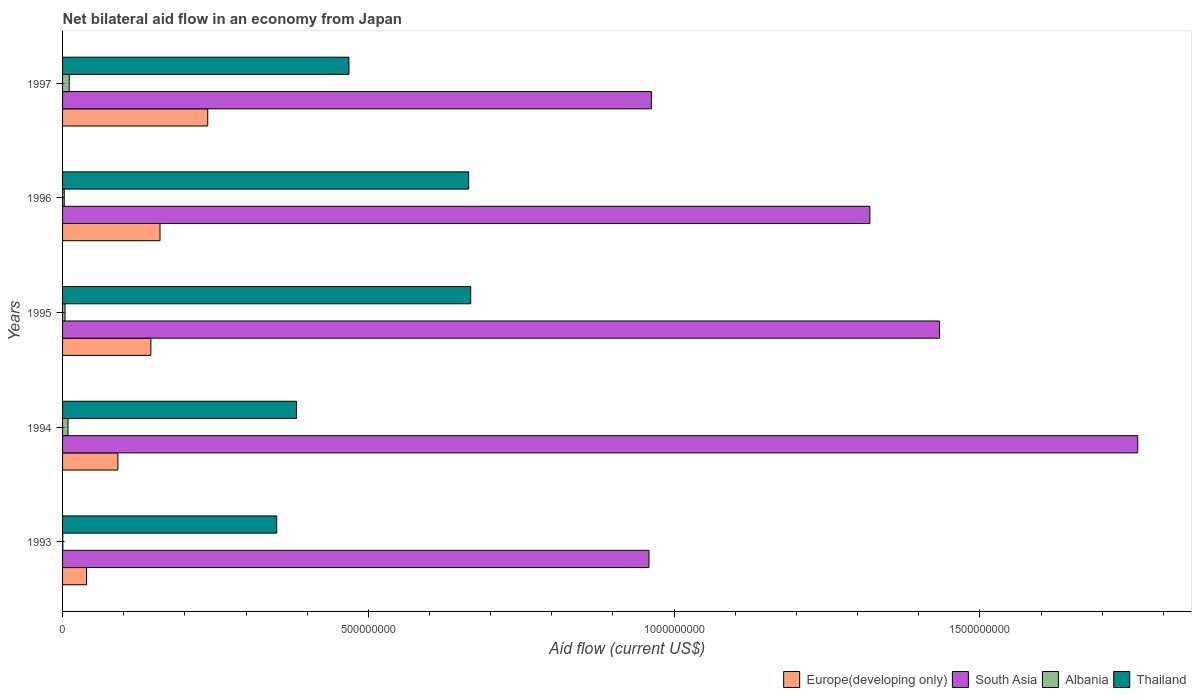How many bars are there on the 5th tick from the top?
Your answer should be very brief. 4. How many bars are there on the 4th tick from the bottom?
Give a very brief answer. 4. What is the label of the 1st group of bars from the top?
Ensure brevity in your answer.  1997. What is the net bilateral aid flow in Albania in 1996?
Your response must be concise. 2.70e+06. Across all years, what is the maximum net bilateral aid flow in South Asia?
Keep it short and to the point. 1.76e+09. Across all years, what is the minimum net bilateral aid flow in Europe(developing only)?
Provide a short and direct response. 3.93e+07. In which year was the net bilateral aid flow in Europe(developing only) maximum?
Keep it short and to the point. 1997. What is the total net bilateral aid flow in Thailand in the graph?
Provide a short and direct response. 2.53e+09. What is the difference between the net bilateral aid flow in Europe(developing only) in 1996 and that in 1997?
Give a very brief answer. -7.80e+07. What is the difference between the net bilateral aid flow in Thailand in 1993 and the net bilateral aid flow in Albania in 1997?
Offer a terse response. 3.39e+08. What is the average net bilateral aid flow in South Asia per year?
Offer a very short reply. 1.29e+09. In the year 1996, what is the difference between the net bilateral aid flow in Albania and net bilateral aid flow in Thailand?
Your answer should be compact. -6.61e+08. What is the ratio of the net bilateral aid flow in South Asia in 1993 to that in 1995?
Provide a short and direct response. 0.67. Is the net bilateral aid flow in Europe(developing only) in 1995 less than that in 1997?
Your response must be concise. Yes. What is the difference between the highest and the second highest net bilateral aid flow in South Asia?
Make the answer very short. 3.24e+08. What is the difference between the highest and the lowest net bilateral aid flow in Albania?
Give a very brief answer. 1.04e+07. In how many years, is the net bilateral aid flow in Europe(developing only) greater than the average net bilateral aid flow in Europe(developing only) taken over all years?
Offer a very short reply. 3. What does the 2nd bar from the top in 1995 represents?
Make the answer very short. Albania. What does the 2nd bar from the bottom in 1997 represents?
Give a very brief answer. South Asia. Is it the case that in every year, the sum of the net bilateral aid flow in Albania and net bilateral aid flow in Thailand is greater than the net bilateral aid flow in South Asia?
Your answer should be compact. No. Are the values on the major ticks of X-axis written in scientific E-notation?
Offer a very short reply. No. Does the graph contain any zero values?
Give a very brief answer. No. Does the graph contain grids?
Offer a very short reply. No. Where does the legend appear in the graph?
Make the answer very short. Bottom right. How many legend labels are there?
Give a very brief answer. 4. What is the title of the graph?
Offer a very short reply. Net bilateral aid flow in an economy from Japan. What is the label or title of the Y-axis?
Offer a terse response. Years. What is the Aid flow (current US$) of Europe(developing only) in 1993?
Provide a short and direct response. 3.93e+07. What is the Aid flow (current US$) of South Asia in 1993?
Provide a short and direct response. 9.59e+08. What is the Aid flow (current US$) of Thailand in 1993?
Keep it short and to the point. 3.50e+08. What is the Aid flow (current US$) in Europe(developing only) in 1994?
Provide a short and direct response. 9.05e+07. What is the Aid flow (current US$) of South Asia in 1994?
Your answer should be very brief. 1.76e+09. What is the Aid flow (current US$) in Albania in 1994?
Your response must be concise. 8.85e+06. What is the Aid flow (current US$) of Thailand in 1994?
Offer a terse response. 3.83e+08. What is the Aid flow (current US$) of Europe(developing only) in 1995?
Provide a succinct answer. 1.44e+08. What is the Aid flow (current US$) of South Asia in 1995?
Make the answer very short. 1.43e+09. What is the Aid flow (current US$) of Albania in 1995?
Your answer should be compact. 4.09e+06. What is the Aid flow (current US$) in Thailand in 1995?
Your answer should be compact. 6.67e+08. What is the Aid flow (current US$) in Europe(developing only) in 1996?
Your answer should be compact. 1.59e+08. What is the Aid flow (current US$) of South Asia in 1996?
Your answer should be very brief. 1.32e+09. What is the Aid flow (current US$) in Albania in 1996?
Give a very brief answer. 2.70e+06. What is the Aid flow (current US$) of Thailand in 1996?
Your response must be concise. 6.64e+08. What is the Aid flow (current US$) of Europe(developing only) in 1997?
Provide a short and direct response. 2.37e+08. What is the Aid flow (current US$) in South Asia in 1997?
Offer a very short reply. 9.63e+08. What is the Aid flow (current US$) in Albania in 1997?
Your answer should be very brief. 1.08e+07. What is the Aid flow (current US$) of Thailand in 1997?
Your answer should be compact. 4.68e+08. Across all years, what is the maximum Aid flow (current US$) of Europe(developing only)?
Provide a short and direct response. 2.37e+08. Across all years, what is the maximum Aid flow (current US$) in South Asia?
Give a very brief answer. 1.76e+09. Across all years, what is the maximum Aid flow (current US$) in Albania?
Your answer should be very brief. 1.08e+07. Across all years, what is the maximum Aid flow (current US$) in Thailand?
Your answer should be compact. 6.67e+08. Across all years, what is the minimum Aid flow (current US$) in Europe(developing only)?
Make the answer very short. 3.93e+07. Across all years, what is the minimum Aid flow (current US$) in South Asia?
Keep it short and to the point. 9.59e+08. Across all years, what is the minimum Aid flow (current US$) of Thailand?
Your response must be concise. 3.50e+08. What is the total Aid flow (current US$) in Europe(developing only) in the graph?
Your answer should be very brief. 6.71e+08. What is the total Aid flow (current US$) in South Asia in the graph?
Give a very brief answer. 6.43e+09. What is the total Aid flow (current US$) in Albania in the graph?
Your answer should be very brief. 2.68e+07. What is the total Aid flow (current US$) of Thailand in the graph?
Provide a short and direct response. 2.53e+09. What is the difference between the Aid flow (current US$) in Europe(developing only) in 1993 and that in 1994?
Offer a very short reply. -5.12e+07. What is the difference between the Aid flow (current US$) of South Asia in 1993 and that in 1994?
Make the answer very short. -7.99e+08. What is the difference between the Aid flow (current US$) of Albania in 1993 and that in 1994?
Make the answer very short. -8.45e+06. What is the difference between the Aid flow (current US$) of Thailand in 1993 and that in 1994?
Offer a terse response. -3.24e+07. What is the difference between the Aid flow (current US$) in Europe(developing only) in 1993 and that in 1995?
Your answer should be compact. -1.05e+08. What is the difference between the Aid flow (current US$) of South Asia in 1993 and that in 1995?
Provide a succinct answer. -4.75e+08. What is the difference between the Aid flow (current US$) of Albania in 1993 and that in 1995?
Your answer should be compact. -3.69e+06. What is the difference between the Aid flow (current US$) in Thailand in 1993 and that in 1995?
Your response must be concise. -3.17e+08. What is the difference between the Aid flow (current US$) of Europe(developing only) in 1993 and that in 1996?
Your response must be concise. -1.20e+08. What is the difference between the Aid flow (current US$) of South Asia in 1993 and that in 1996?
Make the answer very short. -3.61e+08. What is the difference between the Aid flow (current US$) in Albania in 1993 and that in 1996?
Your answer should be very brief. -2.30e+06. What is the difference between the Aid flow (current US$) of Thailand in 1993 and that in 1996?
Ensure brevity in your answer.  -3.14e+08. What is the difference between the Aid flow (current US$) of Europe(developing only) in 1993 and that in 1997?
Keep it short and to the point. -1.98e+08. What is the difference between the Aid flow (current US$) in South Asia in 1993 and that in 1997?
Give a very brief answer. -3.89e+06. What is the difference between the Aid flow (current US$) of Albania in 1993 and that in 1997?
Offer a terse response. -1.04e+07. What is the difference between the Aid flow (current US$) in Thailand in 1993 and that in 1997?
Offer a very short reply. -1.18e+08. What is the difference between the Aid flow (current US$) in Europe(developing only) in 1994 and that in 1995?
Your response must be concise. -5.39e+07. What is the difference between the Aid flow (current US$) of South Asia in 1994 and that in 1995?
Your response must be concise. 3.24e+08. What is the difference between the Aid flow (current US$) of Albania in 1994 and that in 1995?
Your answer should be very brief. 4.76e+06. What is the difference between the Aid flow (current US$) of Thailand in 1994 and that in 1995?
Ensure brevity in your answer.  -2.85e+08. What is the difference between the Aid flow (current US$) of Europe(developing only) in 1994 and that in 1996?
Keep it short and to the point. -6.89e+07. What is the difference between the Aid flow (current US$) of South Asia in 1994 and that in 1996?
Offer a very short reply. 4.38e+08. What is the difference between the Aid flow (current US$) of Albania in 1994 and that in 1996?
Make the answer very short. 6.15e+06. What is the difference between the Aid flow (current US$) of Thailand in 1994 and that in 1996?
Your response must be concise. -2.81e+08. What is the difference between the Aid flow (current US$) in Europe(developing only) in 1994 and that in 1997?
Your answer should be compact. -1.47e+08. What is the difference between the Aid flow (current US$) in South Asia in 1994 and that in 1997?
Give a very brief answer. 7.95e+08. What is the difference between the Aid flow (current US$) of Albania in 1994 and that in 1997?
Offer a terse response. -1.94e+06. What is the difference between the Aid flow (current US$) of Thailand in 1994 and that in 1997?
Provide a succinct answer. -8.57e+07. What is the difference between the Aid flow (current US$) in Europe(developing only) in 1995 and that in 1996?
Ensure brevity in your answer.  -1.50e+07. What is the difference between the Aid flow (current US$) in South Asia in 1995 and that in 1996?
Make the answer very short. 1.14e+08. What is the difference between the Aid flow (current US$) in Albania in 1995 and that in 1996?
Provide a succinct answer. 1.39e+06. What is the difference between the Aid flow (current US$) in Thailand in 1995 and that in 1996?
Your response must be concise. 3.36e+06. What is the difference between the Aid flow (current US$) in Europe(developing only) in 1995 and that in 1997?
Make the answer very short. -9.30e+07. What is the difference between the Aid flow (current US$) in South Asia in 1995 and that in 1997?
Provide a succinct answer. 4.71e+08. What is the difference between the Aid flow (current US$) of Albania in 1995 and that in 1997?
Provide a short and direct response. -6.70e+06. What is the difference between the Aid flow (current US$) in Thailand in 1995 and that in 1997?
Your answer should be very brief. 1.99e+08. What is the difference between the Aid flow (current US$) of Europe(developing only) in 1996 and that in 1997?
Offer a terse response. -7.80e+07. What is the difference between the Aid flow (current US$) in South Asia in 1996 and that in 1997?
Make the answer very short. 3.57e+08. What is the difference between the Aid flow (current US$) in Albania in 1996 and that in 1997?
Give a very brief answer. -8.09e+06. What is the difference between the Aid flow (current US$) in Thailand in 1996 and that in 1997?
Ensure brevity in your answer.  1.96e+08. What is the difference between the Aid flow (current US$) of Europe(developing only) in 1993 and the Aid flow (current US$) of South Asia in 1994?
Your answer should be very brief. -1.72e+09. What is the difference between the Aid flow (current US$) of Europe(developing only) in 1993 and the Aid flow (current US$) of Albania in 1994?
Make the answer very short. 3.04e+07. What is the difference between the Aid flow (current US$) in Europe(developing only) in 1993 and the Aid flow (current US$) in Thailand in 1994?
Provide a succinct answer. -3.43e+08. What is the difference between the Aid flow (current US$) in South Asia in 1993 and the Aid flow (current US$) in Albania in 1994?
Offer a terse response. 9.50e+08. What is the difference between the Aid flow (current US$) of South Asia in 1993 and the Aid flow (current US$) of Thailand in 1994?
Offer a very short reply. 5.76e+08. What is the difference between the Aid flow (current US$) of Albania in 1993 and the Aid flow (current US$) of Thailand in 1994?
Provide a succinct answer. -3.82e+08. What is the difference between the Aid flow (current US$) of Europe(developing only) in 1993 and the Aid flow (current US$) of South Asia in 1995?
Provide a succinct answer. -1.39e+09. What is the difference between the Aid flow (current US$) of Europe(developing only) in 1993 and the Aid flow (current US$) of Albania in 1995?
Give a very brief answer. 3.52e+07. What is the difference between the Aid flow (current US$) in Europe(developing only) in 1993 and the Aid flow (current US$) in Thailand in 1995?
Keep it short and to the point. -6.28e+08. What is the difference between the Aid flow (current US$) of South Asia in 1993 and the Aid flow (current US$) of Albania in 1995?
Your answer should be compact. 9.55e+08. What is the difference between the Aid flow (current US$) of South Asia in 1993 and the Aid flow (current US$) of Thailand in 1995?
Ensure brevity in your answer.  2.91e+08. What is the difference between the Aid flow (current US$) of Albania in 1993 and the Aid flow (current US$) of Thailand in 1995?
Ensure brevity in your answer.  -6.67e+08. What is the difference between the Aid flow (current US$) in Europe(developing only) in 1993 and the Aid flow (current US$) in South Asia in 1996?
Offer a very short reply. -1.28e+09. What is the difference between the Aid flow (current US$) of Europe(developing only) in 1993 and the Aid flow (current US$) of Albania in 1996?
Keep it short and to the point. 3.66e+07. What is the difference between the Aid flow (current US$) of Europe(developing only) in 1993 and the Aid flow (current US$) of Thailand in 1996?
Offer a very short reply. -6.25e+08. What is the difference between the Aid flow (current US$) in South Asia in 1993 and the Aid flow (current US$) in Albania in 1996?
Offer a very short reply. 9.56e+08. What is the difference between the Aid flow (current US$) of South Asia in 1993 and the Aid flow (current US$) of Thailand in 1996?
Provide a succinct answer. 2.95e+08. What is the difference between the Aid flow (current US$) of Albania in 1993 and the Aid flow (current US$) of Thailand in 1996?
Ensure brevity in your answer.  -6.64e+08. What is the difference between the Aid flow (current US$) in Europe(developing only) in 1993 and the Aid flow (current US$) in South Asia in 1997?
Keep it short and to the point. -9.23e+08. What is the difference between the Aid flow (current US$) in Europe(developing only) in 1993 and the Aid flow (current US$) in Albania in 1997?
Your response must be concise. 2.85e+07. What is the difference between the Aid flow (current US$) of Europe(developing only) in 1993 and the Aid flow (current US$) of Thailand in 1997?
Offer a very short reply. -4.29e+08. What is the difference between the Aid flow (current US$) of South Asia in 1993 and the Aid flow (current US$) of Albania in 1997?
Your answer should be compact. 9.48e+08. What is the difference between the Aid flow (current US$) in South Asia in 1993 and the Aid flow (current US$) in Thailand in 1997?
Your response must be concise. 4.91e+08. What is the difference between the Aid flow (current US$) of Albania in 1993 and the Aid flow (current US$) of Thailand in 1997?
Provide a succinct answer. -4.68e+08. What is the difference between the Aid flow (current US$) of Europe(developing only) in 1994 and the Aid flow (current US$) of South Asia in 1995?
Your response must be concise. -1.34e+09. What is the difference between the Aid flow (current US$) in Europe(developing only) in 1994 and the Aid flow (current US$) in Albania in 1995?
Provide a succinct answer. 8.64e+07. What is the difference between the Aid flow (current US$) of Europe(developing only) in 1994 and the Aid flow (current US$) of Thailand in 1995?
Offer a very short reply. -5.77e+08. What is the difference between the Aid flow (current US$) of South Asia in 1994 and the Aid flow (current US$) of Albania in 1995?
Your answer should be compact. 1.75e+09. What is the difference between the Aid flow (current US$) of South Asia in 1994 and the Aid flow (current US$) of Thailand in 1995?
Your answer should be very brief. 1.09e+09. What is the difference between the Aid flow (current US$) of Albania in 1994 and the Aid flow (current US$) of Thailand in 1995?
Ensure brevity in your answer.  -6.59e+08. What is the difference between the Aid flow (current US$) of Europe(developing only) in 1994 and the Aid flow (current US$) of South Asia in 1996?
Your answer should be very brief. -1.23e+09. What is the difference between the Aid flow (current US$) of Europe(developing only) in 1994 and the Aid flow (current US$) of Albania in 1996?
Your answer should be very brief. 8.78e+07. What is the difference between the Aid flow (current US$) of Europe(developing only) in 1994 and the Aid flow (current US$) of Thailand in 1996?
Provide a succinct answer. -5.74e+08. What is the difference between the Aid flow (current US$) in South Asia in 1994 and the Aid flow (current US$) in Albania in 1996?
Provide a succinct answer. 1.76e+09. What is the difference between the Aid flow (current US$) in South Asia in 1994 and the Aid flow (current US$) in Thailand in 1996?
Your response must be concise. 1.09e+09. What is the difference between the Aid flow (current US$) in Albania in 1994 and the Aid flow (current US$) in Thailand in 1996?
Offer a very short reply. -6.55e+08. What is the difference between the Aid flow (current US$) of Europe(developing only) in 1994 and the Aid flow (current US$) of South Asia in 1997?
Offer a terse response. -8.72e+08. What is the difference between the Aid flow (current US$) in Europe(developing only) in 1994 and the Aid flow (current US$) in Albania in 1997?
Provide a succinct answer. 7.97e+07. What is the difference between the Aid flow (current US$) of Europe(developing only) in 1994 and the Aid flow (current US$) of Thailand in 1997?
Ensure brevity in your answer.  -3.78e+08. What is the difference between the Aid flow (current US$) in South Asia in 1994 and the Aid flow (current US$) in Albania in 1997?
Provide a short and direct response. 1.75e+09. What is the difference between the Aid flow (current US$) of South Asia in 1994 and the Aid flow (current US$) of Thailand in 1997?
Keep it short and to the point. 1.29e+09. What is the difference between the Aid flow (current US$) of Albania in 1994 and the Aid flow (current US$) of Thailand in 1997?
Keep it short and to the point. -4.59e+08. What is the difference between the Aid flow (current US$) in Europe(developing only) in 1995 and the Aid flow (current US$) in South Asia in 1996?
Offer a terse response. -1.18e+09. What is the difference between the Aid flow (current US$) in Europe(developing only) in 1995 and the Aid flow (current US$) in Albania in 1996?
Give a very brief answer. 1.42e+08. What is the difference between the Aid flow (current US$) in Europe(developing only) in 1995 and the Aid flow (current US$) in Thailand in 1996?
Provide a succinct answer. -5.20e+08. What is the difference between the Aid flow (current US$) of South Asia in 1995 and the Aid flow (current US$) of Albania in 1996?
Offer a terse response. 1.43e+09. What is the difference between the Aid flow (current US$) of South Asia in 1995 and the Aid flow (current US$) of Thailand in 1996?
Offer a terse response. 7.70e+08. What is the difference between the Aid flow (current US$) of Albania in 1995 and the Aid flow (current US$) of Thailand in 1996?
Offer a terse response. -6.60e+08. What is the difference between the Aid flow (current US$) in Europe(developing only) in 1995 and the Aid flow (current US$) in South Asia in 1997?
Give a very brief answer. -8.18e+08. What is the difference between the Aid flow (current US$) in Europe(developing only) in 1995 and the Aid flow (current US$) in Albania in 1997?
Your response must be concise. 1.34e+08. What is the difference between the Aid flow (current US$) of Europe(developing only) in 1995 and the Aid flow (current US$) of Thailand in 1997?
Provide a succinct answer. -3.24e+08. What is the difference between the Aid flow (current US$) of South Asia in 1995 and the Aid flow (current US$) of Albania in 1997?
Keep it short and to the point. 1.42e+09. What is the difference between the Aid flow (current US$) in South Asia in 1995 and the Aid flow (current US$) in Thailand in 1997?
Give a very brief answer. 9.66e+08. What is the difference between the Aid flow (current US$) of Albania in 1995 and the Aid flow (current US$) of Thailand in 1997?
Keep it short and to the point. -4.64e+08. What is the difference between the Aid flow (current US$) in Europe(developing only) in 1996 and the Aid flow (current US$) in South Asia in 1997?
Offer a very short reply. -8.03e+08. What is the difference between the Aid flow (current US$) of Europe(developing only) in 1996 and the Aid flow (current US$) of Albania in 1997?
Your answer should be very brief. 1.49e+08. What is the difference between the Aid flow (current US$) in Europe(developing only) in 1996 and the Aid flow (current US$) in Thailand in 1997?
Your response must be concise. -3.09e+08. What is the difference between the Aid flow (current US$) of South Asia in 1996 and the Aid flow (current US$) of Albania in 1997?
Your answer should be very brief. 1.31e+09. What is the difference between the Aid flow (current US$) of South Asia in 1996 and the Aid flow (current US$) of Thailand in 1997?
Offer a very short reply. 8.52e+08. What is the difference between the Aid flow (current US$) in Albania in 1996 and the Aid flow (current US$) in Thailand in 1997?
Offer a terse response. -4.66e+08. What is the average Aid flow (current US$) of Europe(developing only) per year?
Provide a short and direct response. 1.34e+08. What is the average Aid flow (current US$) of South Asia per year?
Keep it short and to the point. 1.29e+09. What is the average Aid flow (current US$) in Albania per year?
Keep it short and to the point. 5.37e+06. What is the average Aid flow (current US$) of Thailand per year?
Offer a very short reply. 5.06e+08. In the year 1993, what is the difference between the Aid flow (current US$) of Europe(developing only) and Aid flow (current US$) of South Asia?
Your answer should be compact. -9.20e+08. In the year 1993, what is the difference between the Aid flow (current US$) in Europe(developing only) and Aid flow (current US$) in Albania?
Provide a succinct answer. 3.89e+07. In the year 1993, what is the difference between the Aid flow (current US$) of Europe(developing only) and Aid flow (current US$) of Thailand?
Offer a very short reply. -3.11e+08. In the year 1993, what is the difference between the Aid flow (current US$) in South Asia and Aid flow (current US$) in Albania?
Your answer should be very brief. 9.58e+08. In the year 1993, what is the difference between the Aid flow (current US$) of South Asia and Aid flow (current US$) of Thailand?
Provide a short and direct response. 6.09e+08. In the year 1993, what is the difference between the Aid flow (current US$) in Albania and Aid flow (current US$) in Thailand?
Offer a very short reply. -3.50e+08. In the year 1994, what is the difference between the Aid flow (current US$) of Europe(developing only) and Aid flow (current US$) of South Asia?
Offer a very short reply. -1.67e+09. In the year 1994, what is the difference between the Aid flow (current US$) of Europe(developing only) and Aid flow (current US$) of Albania?
Make the answer very short. 8.16e+07. In the year 1994, what is the difference between the Aid flow (current US$) of Europe(developing only) and Aid flow (current US$) of Thailand?
Provide a short and direct response. -2.92e+08. In the year 1994, what is the difference between the Aid flow (current US$) of South Asia and Aid flow (current US$) of Albania?
Provide a succinct answer. 1.75e+09. In the year 1994, what is the difference between the Aid flow (current US$) in South Asia and Aid flow (current US$) in Thailand?
Make the answer very short. 1.38e+09. In the year 1994, what is the difference between the Aid flow (current US$) of Albania and Aid flow (current US$) of Thailand?
Your response must be concise. -3.74e+08. In the year 1995, what is the difference between the Aid flow (current US$) of Europe(developing only) and Aid flow (current US$) of South Asia?
Your answer should be very brief. -1.29e+09. In the year 1995, what is the difference between the Aid flow (current US$) of Europe(developing only) and Aid flow (current US$) of Albania?
Provide a succinct answer. 1.40e+08. In the year 1995, what is the difference between the Aid flow (current US$) of Europe(developing only) and Aid flow (current US$) of Thailand?
Your response must be concise. -5.23e+08. In the year 1995, what is the difference between the Aid flow (current US$) in South Asia and Aid flow (current US$) in Albania?
Offer a terse response. 1.43e+09. In the year 1995, what is the difference between the Aid flow (current US$) in South Asia and Aid flow (current US$) in Thailand?
Provide a succinct answer. 7.67e+08. In the year 1995, what is the difference between the Aid flow (current US$) in Albania and Aid flow (current US$) in Thailand?
Offer a terse response. -6.63e+08. In the year 1996, what is the difference between the Aid flow (current US$) of Europe(developing only) and Aid flow (current US$) of South Asia?
Offer a terse response. -1.16e+09. In the year 1996, what is the difference between the Aid flow (current US$) of Europe(developing only) and Aid flow (current US$) of Albania?
Ensure brevity in your answer.  1.57e+08. In the year 1996, what is the difference between the Aid flow (current US$) of Europe(developing only) and Aid flow (current US$) of Thailand?
Your answer should be compact. -5.05e+08. In the year 1996, what is the difference between the Aid flow (current US$) of South Asia and Aid flow (current US$) of Albania?
Give a very brief answer. 1.32e+09. In the year 1996, what is the difference between the Aid flow (current US$) in South Asia and Aid flow (current US$) in Thailand?
Provide a short and direct response. 6.56e+08. In the year 1996, what is the difference between the Aid flow (current US$) in Albania and Aid flow (current US$) in Thailand?
Offer a terse response. -6.61e+08. In the year 1997, what is the difference between the Aid flow (current US$) of Europe(developing only) and Aid flow (current US$) of South Asia?
Ensure brevity in your answer.  -7.25e+08. In the year 1997, what is the difference between the Aid flow (current US$) in Europe(developing only) and Aid flow (current US$) in Albania?
Keep it short and to the point. 2.27e+08. In the year 1997, what is the difference between the Aid flow (current US$) in Europe(developing only) and Aid flow (current US$) in Thailand?
Keep it short and to the point. -2.31e+08. In the year 1997, what is the difference between the Aid flow (current US$) of South Asia and Aid flow (current US$) of Albania?
Offer a very short reply. 9.52e+08. In the year 1997, what is the difference between the Aid flow (current US$) of South Asia and Aid flow (current US$) of Thailand?
Give a very brief answer. 4.94e+08. In the year 1997, what is the difference between the Aid flow (current US$) of Albania and Aid flow (current US$) of Thailand?
Ensure brevity in your answer.  -4.57e+08. What is the ratio of the Aid flow (current US$) of Europe(developing only) in 1993 to that in 1994?
Offer a terse response. 0.43. What is the ratio of the Aid flow (current US$) of South Asia in 1993 to that in 1994?
Provide a succinct answer. 0.55. What is the ratio of the Aid flow (current US$) in Albania in 1993 to that in 1994?
Provide a short and direct response. 0.05. What is the ratio of the Aid flow (current US$) of Thailand in 1993 to that in 1994?
Provide a succinct answer. 0.92. What is the ratio of the Aid flow (current US$) in Europe(developing only) in 1993 to that in 1995?
Ensure brevity in your answer.  0.27. What is the ratio of the Aid flow (current US$) in South Asia in 1993 to that in 1995?
Provide a short and direct response. 0.67. What is the ratio of the Aid flow (current US$) of Albania in 1993 to that in 1995?
Provide a short and direct response. 0.1. What is the ratio of the Aid flow (current US$) in Thailand in 1993 to that in 1995?
Give a very brief answer. 0.52. What is the ratio of the Aid flow (current US$) in Europe(developing only) in 1993 to that in 1996?
Give a very brief answer. 0.25. What is the ratio of the Aid flow (current US$) of South Asia in 1993 to that in 1996?
Your response must be concise. 0.73. What is the ratio of the Aid flow (current US$) in Albania in 1993 to that in 1996?
Offer a very short reply. 0.15. What is the ratio of the Aid flow (current US$) in Thailand in 1993 to that in 1996?
Offer a terse response. 0.53. What is the ratio of the Aid flow (current US$) of Europe(developing only) in 1993 to that in 1997?
Provide a short and direct response. 0.17. What is the ratio of the Aid flow (current US$) of South Asia in 1993 to that in 1997?
Your answer should be compact. 1. What is the ratio of the Aid flow (current US$) in Albania in 1993 to that in 1997?
Provide a short and direct response. 0.04. What is the ratio of the Aid flow (current US$) of Thailand in 1993 to that in 1997?
Give a very brief answer. 0.75. What is the ratio of the Aid flow (current US$) in Europe(developing only) in 1994 to that in 1995?
Offer a very short reply. 0.63. What is the ratio of the Aid flow (current US$) of South Asia in 1994 to that in 1995?
Make the answer very short. 1.23. What is the ratio of the Aid flow (current US$) of Albania in 1994 to that in 1995?
Ensure brevity in your answer.  2.16. What is the ratio of the Aid flow (current US$) in Thailand in 1994 to that in 1995?
Your response must be concise. 0.57. What is the ratio of the Aid flow (current US$) of Europe(developing only) in 1994 to that in 1996?
Give a very brief answer. 0.57. What is the ratio of the Aid flow (current US$) in South Asia in 1994 to that in 1996?
Your answer should be very brief. 1.33. What is the ratio of the Aid flow (current US$) of Albania in 1994 to that in 1996?
Provide a short and direct response. 3.28. What is the ratio of the Aid flow (current US$) of Thailand in 1994 to that in 1996?
Keep it short and to the point. 0.58. What is the ratio of the Aid flow (current US$) of Europe(developing only) in 1994 to that in 1997?
Your answer should be compact. 0.38. What is the ratio of the Aid flow (current US$) in South Asia in 1994 to that in 1997?
Ensure brevity in your answer.  1.83. What is the ratio of the Aid flow (current US$) in Albania in 1994 to that in 1997?
Make the answer very short. 0.82. What is the ratio of the Aid flow (current US$) in Thailand in 1994 to that in 1997?
Your answer should be very brief. 0.82. What is the ratio of the Aid flow (current US$) in Europe(developing only) in 1995 to that in 1996?
Your answer should be very brief. 0.91. What is the ratio of the Aid flow (current US$) in South Asia in 1995 to that in 1996?
Your answer should be very brief. 1.09. What is the ratio of the Aid flow (current US$) of Albania in 1995 to that in 1996?
Keep it short and to the point. 1.51. What is the ratio of the Aid flow (current US$) of Thailand in 1995 to that in 1996?
Keep it short and to the point. 1.01. What is the ratio of the Aid flow (current US$) of Europe(developing only) in 1995 to that in 1997?
Ensure brevity in your answer.  0.61. What is the ratio of the Aid flow (current US$) of South Asia in 1995 to that in 1997?
Give a very brief answer. 1.49. What is the ratio of the Aid flow (current US$) in Albania in 1995 to that in 1997?
Provide a succinct answer. 0.38. What is the ratio of the Aid flow (current US$) of Thailand in 1995 to that in 1997?
Your answer should be very brief. 1.43. What is the ratio of the Aid flow (current US$) of Europe(developing only) in 1996 to that in 1997?
Your answer should be very brief. 0.67. What is the ratio of the Aid flow (current US$) of South Asia in 1996 to that in 1997?
Ensure brevity in your answer.  1.37. What is the ratio of the Aid flow (current US$) of Albania in 1996 to that in 1997?
Give a very brief answer. 0.25. What is the ratio of the Aid flow (current US$) in Thailand in 1996 to that in 1997?
Make the answer very short. 1.42. What is the difference between the highest and the second highest Aid flow (current US$) of Europe(developing only)?
Keep it short and to the point. 7.80e+07. What is the difference between the highest and the second highest Aid flow (current US$) of South Asia?
Provide a short and direct response. 3.24e+08. What is the difference between the highest and the second highest Aid flow (current US$) in Albania?
Your answer should be very brief. 1.94e+06. What is the difference between the highest and the second highest Aid flow (current US$) of Thailand?
Provide a short and direct response. 3.36e+06. What is the difference between the highest and the lowest Aid flow (current US$) in Europe(developing only)?
Your answer should be very brief. 1.98e+08. What is the difference between the highest and the lowest Aid flow (current US$) in South Asia?
Give a very brief answer. 7.99e+08. What is the difference between the highest and the lowest Aid flow (current US$) in Albania?
Provide a short and direct response. 1.04e+07. What is the difference between the highest and the lowest Aid flow (current US$) in Thailand?
Offer a very short reply. 3.17e+08. 